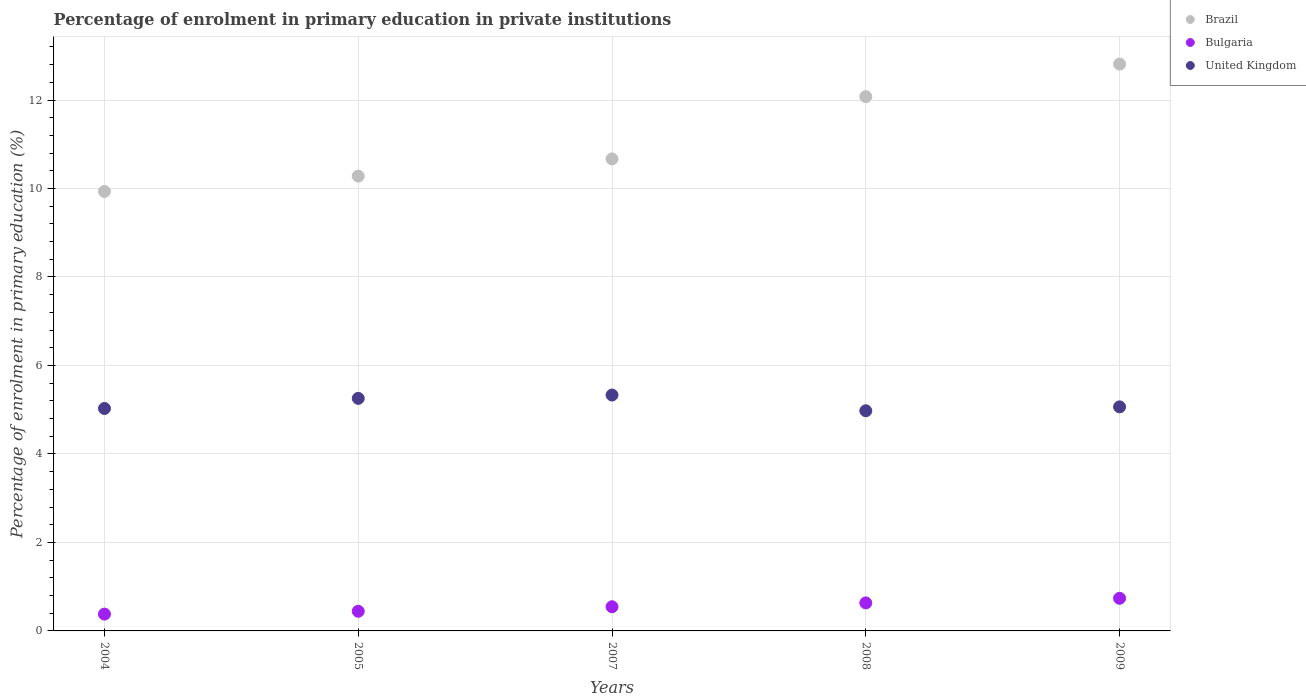How many different coloured dotlines are there?
Make the answer very short. 3. What is the percentage of enrolment in primary education in Bulgaria in 2004?
Your answer should be compact. 0.38. Across all years, what is the maximum percentage of enrolment in primary education in United Kingdom?
Provide a short and direct response. 5.33. Across all years, what is the minimum percentage of enrolment in primary education in United Kingdom?
Give a very brief answer. 4.98. In which year was the percentage of enrolment in primary education in Brazil minimum?
Ensure brevity in your answer.  2004. What is the total percentage of enrolment in primary education in Bulgaria in the graph?
Provide a short and direct response. 2.74. What is the difference between the percentage of enrolment in primary education in United Kingdom in 2005 and that in 2007?
Provide a short and direct response. -0.08. What is the difference between the percentage of enrolment in primary education in Brazil in 2005 and the percentage of enrolment in primary education in United Kingdom in 2009?
Make the answer very short. 5.22. What is the average percentage of enrolment in primary education in United Kingdom per year?
Your answer should be very brief. 5.13. In the year 2009, what is the difference between the percentage of enrolment in primary education in Brazil and percentage of enrolment in primary education in United Kingdom?
Your response must be concise. 7.75. What is the ratio of the percentage of enrolment in primary education in Brazil in 2005 to that in 2009?
Keep it short and to the point. 0.8. Is the percentage of enrolment in primary education in Bulgaria in 2004 less than that in 2008?
Your answer should be compact. Yes. Is the difference between the percentage of enrolment in primary education in Brazil in 2008 and 2009 greater than the difference between the percentage of enrolment in primary education in United Kingdom in 2008 and 2009?
Your answer should be compact. No. What is the difference between the highest and the second highest percentage of enrolment in primary education in United Kingdom?
Provide a short and direct response. 0.08. What is the difference between the highest and the lowest percentage of enrolment in primary education in United Kingdom?
Provide a succinct answer. 0.36. In how many years, is the percentage of enrolment in primary education in Brazil greater than the average percentage of enrolment in primary education in Brazil taken over all years?
Your response must be concise. 2. Does the percentage of enrolment in primary education in Brazil monotonically increase over the years?
Ensure brevity in your answer.  Yes. Is the percentage of enrolment in primary education in Brazil strictly less than the percentage of enrolment in primary education in Bulgaria over the years?
Ensure brevity in your answer.  No. How many dotlines are there?
Your response must be concise. 3. Are the values on the major ticks of Y-axis written in scientific E-notation?
Your answer should be very brief. No. Does the graph contain any zero values?
Provide a short and direct response. No. Does the graph contain grids?
Offer a terse response. Yes. Where does the legend appear in the graph?
Keep it short and to the point. Top right. What is the title of the graph?
Give a very brief answer. Percentage of enrolment in primary education in private institutions. What is the label or title of the X-axis?
Provide a short and direct response. Years. What is the label or title of the Y-axis?
Your answer should be very brief. Percentage of enrolment in primary education (%). What is the Percentage of enrolment in primary education (%) in Brazil in 2004?
Your response must be concise. 9.93. What is the Percentage of enrolment in primary education (%) in Bulgaria in 2004?
Ensure brevity in your answer.  0.38. What is the Percentage of enrolment in primary education (%) of United Kingdom in 2004?
Provide a short and direct response. 5.03. What is the Percentage of enrolment in primary education (%) of Brazil in 2005?
Your response must be concise. 10.28. What is the Percentage of enrolment in primary education (%) in Bulgaria in 2005?
Provide a succinct answer. 0.44. What is the Percentage of enrolment in primary education (%) of United Kingdom in 2005?
Provide a short and direct response. 5.26. What is the Percentage of enrolment in primary education (%) of Brazil in 2007?
Offer a terse response. 10.67. What is the Percentage of enrolment in primary education (%) of Bulgaria in 2007?
Your answer should be compact. 0.55. What is the Percentage of enrolment in primary education (%) of United Kingdom in 2007?
Offer a terse response. 5.33. What is the Percentage of enrolment in primary education (%) in Brazil in 2008?
Provide a short and direct response. 12.08. What is the Percentage of enrolment in primary education (%) in Bulgaria in 2008?
Offer a terse response. 0.63. What is the Percentage of enrolment in primary education (%) in United Kingdom in 2008?
Ensure brevity in your answer.  4.98. What is the Percentage of enrolment in primary education (%) in Brazil in 2009?
Keep it short and to the point. 12.81. What is the Percentage of enrolment in primary education (%) in Bulgaria in 2009?
Make the answer very short. 0.74. What is the Percentage of enrolment in primary education (%) in United Kingdom in 2009?
Offer a terse response. 5.06. Across all years, what is the maximum Percentage of enrolment in primary education (%) in Brazil?
Keep it short and to the point. 12.81. Across all years, what is the maximum Percentage of enrolment in primary education (%) of Bulgaria?
Your answer should be compact. 0.74. Across all years, what is the maximum Percentage of enrolment in primary education (%) in United Kingdom?
Your answer should be very brief. 5.33. Across all years, what is the minimum Percentage of enrolment in primary education (%) of Brazil?
Offer a very short reply. 9.93. Across all years, what is the minimum Percentage of enrolment in primary education (%) of Bulgaria?
Give a very brief answer. 0.38. Across all years, what is the minimum Percentage of enrolment in primary education (%) of United Kingdom?
Your answer should be very brief. 4.98. What is the total Percentage of enrolment in primary education (%) of Brazil in the graph?
Provide a short and direct response. 55.77. What is the total Percentage of enrolment in primary education (%) of Bulgaria in the graph?
Provide a short and direct response. 2.74. What is the total Percentage of enrolment in primary education (%) of United Kingdom in the graph?
Offer a very short reply. 25.66. What is the difference between the Percentage of enrolment in primary education (%) in Brazil in 2004 and that in 2005?
Make the answer very short. -0.35. What is the difference between the Percentage of enrolment in primary education (%) in Bulgaria in 2004 and that in 2005?
Offer a terse response. -0.06. What is the difference between the Percentage of enrolment in primary education (%) in United Kingdom in 2004 and that in 2005?
Offer a very short reply. -0.23. What is the difference between the Percentage of enrolment in primary education (%) of Brazil in 2004 and that in 2007?
Ensure brevity in your answer.  -0.74. What is the difference between the Percentage of enrolment in primary education (%) of Bulgaria in 2004 and that in 2007?
Provide a short and direct response. -0.17. What is the difference between the Percentage of enrolment in primary education (%) in United Kingdom in 2004 and that in 2007?
Provide a short and direct response. -0.3. What is the difference between the Percentage of enrolment in primary education (%) in Brazil in 2004 and that in 2008?
Provide a short and direct response. -2.14. What is the difference between the Percentage of enrolment in primary education (%) of Bulgaria in 2004 and that in 2008?
Provide a succinct answer. -0.25. What is the difference between the Percentage of enrolment in primary education (%) in United Kingdom in 2004 and that in 2008?
Offer a terse response. 0.05. What is the difference between the Percentage of enrolment in primary education (%) of Brazil in 2004 and that in 2009?
Make the answer very short. -2.88. What is the difference between the Percentage of enrolment in primary education (%) of Bulgaria in 2004 and that in 2009?
Keep it short and to the point. -0.36. What is the difference between the Percentage of enrolment in primary education (%) of United Kingdom in 2004 and that in 2009?
Offer a very short reply. -0.04. What is the difference between the Percentage of enrolment in primary education (%) of Brazil in 2005 and that in 2007?
Provide a short and direct response. -0.39. What is the difference between the Percentage of enrolment in primary education (%) in Bulgaria in 2005 and that in 2007?
Keep it short and to the point. -0.1. What is the difference between the Percentage of enrolment in primary education (%) in United Kingdom in 2005 and that in 2007?
Your answer should be compact. -0.08. What is the difference between the Percentage of enrolment in primary education (%) in Brazil in 2005 and that in 2008?
Your answer should be compact. -1.8. What is the difference between the Percentage of enrolment in primary education (%) in Bulgaria in 2005 and that in 2008?
Keep it short and to the point. -0.19. What is the difference between the Percentage of enrolment in primary education (%) of United Kingdom in 2005 and that in 2008?
Provide a succinct answer. 0.28. What is the difference between the Percentage of enrolment in primary education (%) in Brazil in 2005 and that in 2009?
Give a very brief answer. -2.53. What is the difference between the Percentage of enrolment in primary education (%) in Bulgaria in 2005 and that in 2009?
Make the answer very short. -0.29. What is the difference between the Percentage of enrolment in primary education (%) in United Kingdom in 2005 and that in 2009?
Your answer should be compact. 0.19. What is the difference between the Percentage of enrolment in primary education (%) of Brazil in 2007 and that in 2008?
Ensure brevity in your answer.  -1.41. What is the difference between the Percentage of enrolment in primary education (%) in Bulgaria in 2007 and that in 2008?
Ensure brevity in your answer.  -0.09. What is the difference between the Percentage of enrolment in primary education (%) of United Kingdom in 2007 and that in 2008?
Your response must be concise. 0.36. What is the difference between the Percentage of enrolment in primary education (%) in Brazil in 2007 and that in 2009?
Provide a short and direct response. -2.14. What is the difference between the Percentage of enrolment in primary education (%) of Bulgaria in 2007 and that in 2009?
Make the answer very short. -0.19. What is the difference between the Percentage of enrolment in primary education (%) of United Kingdom in 2007 and that in 2009?
Offer a very short reply. 0.27. What is the difference between the Percentage of enrolment in primary education (%) in Brazil in 2008 and that in 2009?
Make the answer very short. -0.74. What is the difference between the Percentage of enrolment in primary education (%) in Bulgaria in 2008 and that in 2009?
Give a very brief answer. -0.1. What is the difference between the Percentage of enrolment in primary education (%) of United Kingdom in 2008 and that in 2009?
Provide a succinct answer. -0.09. What is the difference between the Percentage of enrolment in primary education (%) of Brazil in 2004 and the Percentage of enrolment in primary education (%) of Bulgaria in 2005?
Your response must be concise. 9.49. What is the difference between the Percentage of enrolment in primary education (%) in Brazil in 2004 and the Percentage of enrolment in primary education (%) in United Kingdom in 2005?
Your answer should be compact. 4.68. What is the difference between the Percentage of enrolment in primary education (%) of Bulgaria in 2004 and the Percentage of enrolment in primary education (%) of United Kingdom in 2005?
Your answer should be very brief. -4.88. What is the difference between the Percentage of enrolment in primary education (%) in Brazil in 2004 and the Percentage of enrolment in primary education (%) in Bulgaria in 2007?
Offer a very short reply. 9.39. What is the difference between the Percentage of enrolment in primary education (%) in Brazil in 2004 and the Percentage of enrolment in primary education (%) in United Kingdom in 2007?
Your answer should be compact. 4.6. What is the difference between the Percentage of enrolment in primary education (%) of Bulgaria in 2004 and the Percentage of enrolment in primary education (%) of United Kingdom in 2007?
Your response must be concise. -4.95. What is the difference between the Percentage of enrolment in primary education (%) in Brazil in 2004 and the Percentage of enrolment in primary education (%) in United Kingdom in 2008?
Make the answer very short. 4.96. What is the difference between the Percentage of enrolment in primary education (%) in Bulgaria in 2004 and the Percentage of enrolment in primary education (%) in United Kingdom in 2008?
Your answer should be very brief. -4.6. What is the difference between the Percentage of enrolment in primary education (%) in Brazil in 2004 and the Percentage of enrolment in primary education (%) in Bulgaria in 2009?
Make the answer very short. 9.2. What is the difference between the Percentage of enrolment in primary education (%) in Brazil in 2004 and the Percentage of enrolment in primary education (%) in United Kingdom in 2009?
Keep it short and to the point. 4.87. What is the difference between the Percentage of enrolment in primary education (%) in Bulgaria in 2004 and the Percentage of enrolment in primary education (%) in United Kingdom in 2009?
Make the answer very short. -4.68. What is the difference between the Percentage of enrolment in primary education (%) in Brazil in 2005 and the Percentage of enrolment in primary education (%) in Bulgaria in 2007?
Provide a short and direct response. 9.73. What is the difference between the Percentage of enrolment in primary education (%) of Brazil in 2005 and the Percentage of enrolment in primary education (%) of United Kingdom in 2007?
Your response must be concise. 4.95. What is the difference between the Percentage of enrolment in primary education (%) of Bulgaria in 2005 and the Percentage of enrolment in primary education (%) of United Kingdom in 2007?
Your answer should be very brief. -4.89. What is the difference between the Percentage of enrolment in primary education (%) of Brazil in 2005 and the Percentage of enrolment in primary education (%) of Bulgaria in 2008?
Make the answer very short. 9.65. What is the difference between the Percentage of enrolment in primary education (%) in Brazil in 2005 and the Percentage of enrolment in primary education (%) in United Kingdom in 2008?
Your answer should be compact. 5.3. What is the difference between the Percentage of enrolment in primary education (%) of Bulgaria in 2005 and the Percentage of enrolment in primary education (%) of United Kingdom in 2008?
Your answer should be very brief. -4.53. What is the difference between the Percentage of enrolment in primary education (%) in Brazil in 2005 and the Percentage of enrolment in primary education (%) in Bulgaria in 2009?
Your answer should be compact. 9.54. What is the difference between the Percentage of enrolment in primary education (%) of Brazil in 2005 and the Percentage of enrolment in primary education (%) of United Kingdom in 2009?
Keep it short and to the point. 5.22. What is the difference between the Percentage of enrolment in primary education (%) of Bulgaria in 2005 and the Percentage of enrolment in primary education (%) of United Kingdom in 2009?
Your answer should be very brief. -4.62. What is the difference between the Percentage of enrolment in primary education (%) in Brazil in 2007 and the Percentage of enrolment in primary education (%) in Bulgaria in 2008?
Make the answer very short. 10.04. What is the difference between the Percentage of enrolment in primary education (%) in Brazil in 2007 and the Percentage of enrolment in primary education (%) in United Kingdom in 2008?
Give a very brief answer. 5.69. What is the difference between the Percentage of enrolment in primary education (%) of Bulgaria in 2007 and the Percentage of enrolment in primary education (%) of United Kingdom in 2008?
Keep it short and to the point. -4.43. What is the difference between the Percentage of enrolment in primary education (%) in Brazil in 2007 and the Percentage of enrolment in primary education (%) in Bulgaria in 2009?
Offer a terse response. 9.93. What is the difference between the Percentage of enrolment in primary education (%) in Brazil in 2007 and the Percentage of enrolment in primary education (%) in United Kingdom in 2009?
Your answer should be very brief. 5.6. What is the difference between the Percentage of enrolment in primary education (%) of Bulgaria in 2007 and the Percentage of enrolment in primary education (%) of United Kingdom in 2009?
Provide a succinct answer. -4.52. What is the difference between the Percentage of enrolment in primary education (%) in Brazil in 2008 and the Percentage of enrolment in primary education (%) in Bulgaria in 2009?
Provide a short and direct response. 11.34. What is the difference between the Percentage of enrolment in primary education (%) in Brazil in 2008 and the Percentage of enrolment in primary education (%) in United Kingdom in 2009?
Offer a terse response. 7.01. What is the difference between the Percentage of enrolment in primary education (%) in Bulgaria in 2008 and the Percentage of enrolment in primary education (%) in United Kingdom in 2009?
Keep it short and to the point. -4.43. What is the average Percentage of enrolment in primary education (%) in Brazil per year?
Ensure brevity in your answer.  11.15. What is the average Percentage of enrolment in primary education (%) in Bulgaria per year?
Make the answer very short. 0.55. What is the average Percentage of enrolment in primary education (%) in United Kingdom per year?
Ensure brevity in your answer.  5.13. In the year 2004, what is the difference between the Percentage of enrolment in primary education (%) of Brazil and Percentage of enrolment in primary education (%) of Bulgaria?
Your answer should be very brief. 9.55. In the year 2004, what is the difference between the Percentage of enrolment in primary education (%) of Brazil and Percentage of enrolment in primary education (%) of United Kingdom?
Offer a very short reply. 4.91. In the year 2004, what is the difference between the Percentage of enrolment in primary education (%) in Bulgaria and Percentage of enrolment in primary education (%) in United Kingdom?
Ensure brevity in your answer.  -4.65. In the year 2005, what is the difference between the Percentage of enrolment in primary education (%) in Brazil and Percentage of enrolment in primary education (%) in Bulgaria?
Ensure brevity in your answer.  9.84. In the year 2005, what is the difference between the Percentage of enrolment in primary education (%) in Brazil and Percentage of enrolment in primary education (%) in United Kingdom?
Make the answer very short. 5.02. In the year 2005, what is the difference between the Percentage of enrolment in primary education (%) in Bulgaria and Percentage of enrolment in primary education (%) in United Kingdom?
Provide a succinct answer. -4.81. In the year 2007, what is the difference between the Percentage of enrolment in primary education (%) in Brazil and Percentage of enrolment in primary education (%) in Bulgaria?
Make the answer very short. 10.12. In the year 2007, what is the difference between the Percentage of enrolment in primary education (%) of Brazil and Percentage of enrolment in primary education (%) of United Kingdom?
Provide a short and direct response. 5.34. In the year 2007, what is the difference between the Percentage of enrolment in primary education (%) of Bulgaria and Percentage of enrolment in primary education (%) of United Kingdom?
Give a very brief answer. -4.79. In the year 2008, what is the difference between the Percentage of enrolment in primary education (%) in Brazil and Percentage of enrolment in primary education (%) in Bulgaria?
Your answer should be compact. 11.44. In the year 2008, what is the difference between the Percentage of enrolment in primary education (%) of Brazil and Percentage of enrolment in primary education (%) of United Kingdom?
Give a very brief answer. 7.1. In the year 2008, what is the difference between the Percentage of enrolment in primary education (%) in Bulgaria and Percentage of enrolment in primary education (%) in United Kingdom?
Keep it short and to the point. -4.34. In the year 2009, what is the difference between the Percentage of enrolment in primary education (%) of Brazil and Percentage of enrolment in primary education (%) of Bulgaria?
Offer a terse response. 12.08. In the year 2009, what is the difference between the Percentage of enrolment in primary education (%) of Brazil and Percentage of enrolment in primary education (%) of United Kingdom?
Keep it short and to the point. 7.75. In the year 2009, what is the difference between the Percentage of enrolment in primary education (%) in Bulgaria and Percentage of enrolment in primary education (%) in United Kingdom?
Provide a succinct answer. -4.33. What is the ratio of the Percentage of enrolment in primary education (%) in Brazil in 2004 to that in 2005?
Offer a terse response. 0.97. What is the ratio of the Percentage of enrolment in primary education (%) of Bulgaria in 2004 to that in 2005?
Keep it short and to the point. 0.86. What is the ratio of the Percentage of enrolment in primary education (%) of United Kingdom in 2004 to that in 2005?
Give a very brief answer. 0.96. What is the ratio of the Percentage of enrolment in primary education (%) of Bulgaria in 2004 to that in 2007?
Give a very brief answer. 0.7. What is the ratio of the Percentage of enrolment in primary education (%) in United Kingdom in 2004 to that in 2007?
Provide a succinct answer. 0.94. What is the ratio of the Percentage of enrolment in primary education (%) of Brazil in 2004 to that in 2008?
Offer a terse response. 0.82. What is the ratio of the Percentage of enrolment in primary education (%) of Bulgaria in 2004 to that in 2008?
Ensure brevity in your answer.  0.6. What is the ratio of the Percentage of enrolment in primary education (%) of United Kingdom in 2004 to that in 2008?
Offer a terse response. 1.01. What is the ratio of the Percentage of enrolment in primary education (%) of Brazil in 2004 to that in 2009?
Keep it short and to the point. 0.78. What is the ratio of the Percentage of enrolment in primary education (%) of Bulgaria in 2004 to that in 2009?
Ensure brevity in your answer.  0.52. What is the ratio of the Percentage of enrolment in primary education (%) of United Kingdom in 2004 to that in 2009?
Offer a terse response. 0.99. What is the ratio of the Percentage of enrolment in primary education (%) of Brazil in 2005 to that in 2007?
Your answer should be very brief. 0.96. What is the ratio of the Percentage of enrolment in primary education (%) in Bulgaria in 2005 to that in 2007?
Your answer should be compact. 0.81. What is the ratio of the Percentage of enrolment in primary education (%) of United Kingdom in 2005 to that in 2007?
Your answer should be very brief. 0.99. What is the ratio of the Percentage of enrolment in primary education (%) of Brazil in 2005 to that in 2008?
Provide a short and direct response. 0.85. What is the ratio of the Percentage of enrolment in primary education (%) in Bulgaria in 2005 to that in 2008?
Your answer should be very brief. 0.7. What is the ratio of the Percentage of enrolment in primary education (%) of United Kingdom in 2005 to that in 2008?
Provide a succinct answer. 1.06. What is the ratio of the Percentage of enrolment in primary education (%) in Brazil in 2005 to that in 2009?
Offer a terse response. 0.8. What is the ratio of the Percentage of enrolment in primary education (%) in Bulgaria in 2005 to that in 2009?
Your response must be concise. 0.6. What is the ratio of the Percentage of enrolment in primary education (%) of United Kingdom in 2005 to that in 2009?
Your answer should be compact. 1.04. What is the ratio of the Percentage of enrolment in primary education (%) in Brazil in 2007 to that in 2008?
Provide a short and direct response. 0.88. What is the ratio of the Percentage of enrolment in primary education (%) in Bulgaria in 2007 to that in 2008?
Ensure brevity in your answer.  0.86. What is the ratio of the Percentage of enrolment in primary education (%) in United Kingdom in 2007 to that in 2008?
Your answer should be very brief. 1.07. What is the ratio of the Percentage of enrolment in primary education (%) of Brazil in 2007 to that in 2009?
Give a very brief answer. 0.83. What is the ratio of the Percentage of enrolment in primary education (%) in Bulgaria in 2007 to that in 2009?
Offer a very short reply. 0.74. What is the ratio of the Percentage of enrolment in primary education (%) in United Kingdom in 2007 to that in 2009?
Ensure brevity in your answer.  1.05. What is the ratio of the Percentage of enrolment in primary education (%) in Brazil in 2008 to that in 2009?
Your answer should be very brief. 0.94. What is the ratio of the Percentage of enrolment in primary education (%) of Bulgaria in 2008 to that in 2009?
Ensure brevity in your answer.  0.86. What is the ratio of the Percentage of enrolment in primary education (%) of United Kingdom in 2008 to that in 2009?
Provide a short and direct response. 0.98. What is the difference between the highest and the second highest Percentage of enrolment in primary education (%) in Brazil?
Your answer should be compact. 0.74. What is the difference between the highest and the second highest Percentage of enrolment in primary education (%) in Bulgaria?
Give a very brief answer. 0.1. What is the difference between the highest and the second highest Percentage of enrolment in primary education (%) of United Kingdom?
Offer a very short reply. 0.08. What is the difference between the highest and the lowest Percentage of enrolment in primary education (%) of Brazil?
Keep it short and to the point. 2.88. What is the difference between the highest and the lowest Percentage of enrolment in primary education (%) of Bulgaria?
Keep it short and to the point. 0.36. What is the difference between the highest and the lowest Percentage of enrolment in primary education (%) in United Kingdom?
Provide a short and direct response. 0.36. 